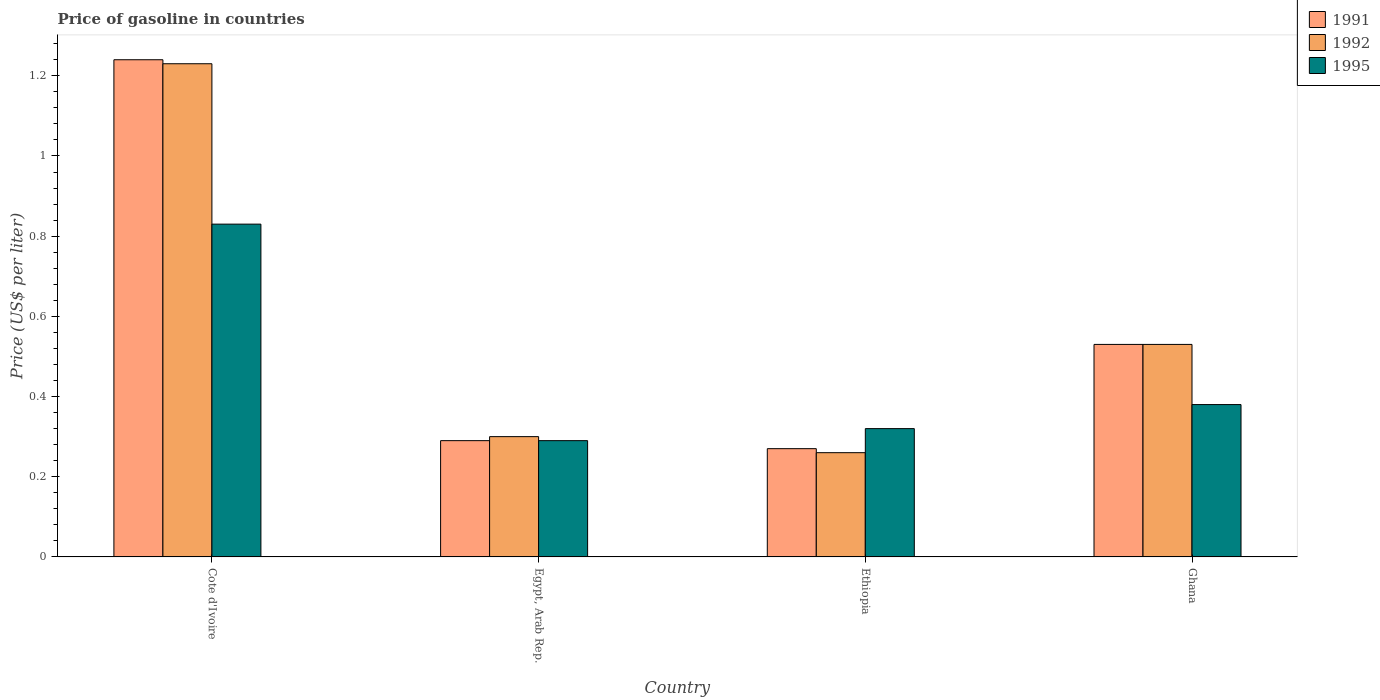How many different coloured bars are there?
Your answer should be compact. 3. Are the number of bars per tick equal to the number of legend labels?
Keep it short and to the point. Yes. How many bars are there on the 3rd tick from the right?
Provide a succinct answer. 3. What is the label of the 2nd group of bars from the left?
Keep it short and to the point. Egypt, Arab Rep. In how many cases, is the number of bars for a given country not equal to the number of legend labels?
Offer a very short reply. 0. What is the price of gasoline in 1992 in Ghana?
Give a very brief answer. 0.53. Across all countries, what is the maximum price of gasoline in 1991?
Make the answer very short. 1.24. Across all countries, what is the minimum price of gasoline in 1992?
Offer a terse response. 0.26. In which country was the price of gasoline in 1992 maximum?
Make the answer very short. Cote d'Ivoire. In which country was the price of gasoline in 1991 minimum?
Your response must be concise. Ethiopia. What is the total price of gasoline in 1995 in the graph?
Make the answer very short. 1.82. What is the difference between the price of gasoline in 1991 in Ethiopia and that in Ghana?
Provide a succinct answer. -0.26. What is the difference between the price of gasoline in 1995 in Ethiopia and the price of gasoline in 1992 in Cote d'Ivoire?
Provide a short and direct response. -0.91. What is the average price of gasoline in 1992 per country?
Your response must be concise. 0.58. What is the difference between the price of gasoline of/in 1991 and price of gasoline of/in 1992 in Ethiopia?
Ensure brevity in your answer.  0.01. In how many countries, is the price of gasoline in 1992 greater than 0.8 US$?
Offer a terse response. 1. What is the ratio of the price of gasoline in 1995 in Egypt, Arab Rep. to that in Ethiopia?
Give a very brief answer. 0.91. Is the price of gasoline in 1995 in Cote d'Ivoire less than that in Egypt, Arab Rep.?
Offer a terse response. No. What is the difference between the highest and the second highest price of gasoline in 1992?
Make the answer very short. -0.7. Is the sum of the price of gasoline in 1991 in Cote d'Ivoire and Ghana greater than the maximum price of gasoline in 1995 across all countries?
Provide a succinct answer. Yes. How many bars are there?
Give a very brief answer. 12. Are all the bars in the graph horizontal?
Make the answer very short. No. Are the values on the major ticks of Y-axis written in scientific E-notation?
Offer a very short reply. No. Does the graph contain grids?
Your answer should be very brief. No. Where does the legend appear in the graph?
Provide a succinct answer. Top right. What is the title of the graph?
Keep it short and to the point. Price of gasoline in countries. What is the label or title of the X-axis?
Offer a very short reply. Country. What is the label or title of the Y-axis?
Keep it short and to the point. Price (US$ per liter). What is the Price (US$ per liter) of 1991 in Cote d'Ivoire?
Offer a very short reply. 1.24. What is the Price (US$ per liter) in 1992 in Cote d'Ivoire?
Make the answer very short. 1.23. What is the Price (US$ per liter) in 1995 in Cote d'Ivoire?
Your answer should be very brief. 0.83. What is the Price (US$ per liter) in 1991 in Egypt, Arab Rep.?
Provide a succinct answer. 0.29. What is the Price (US$ per liter) of 1992 in Egypt, Arab Rep.?
Give a very brief answer. 0.3. What is the Price (US$ per liter) in 1995 in Egypt, Arab Rep.?
Your answer should be very brief. 0.29. What is the Price (US$ per liter) of 1991 in Ethiopia?
Your answer should be very brief. 0.27. What is the Price (US$ per liter) in 1992 in Ethiopia?
Your response must be concise. 0.26. What is the Price (US$ per liter) of 1995 in Ethiopia?
Ensure brevity in your answer.  0.32. What is the Price (US$ per liter) in 1991 in Ghana?
Give a very brief answer. 0.53. What is the Price (US$ per liter) in 1992 in Ghana?
Offer a very short reply. 0.53. What is the Price (US$ per liter) in 1995 in Ghana?
Your answer should be compact. 0.38. Across all countries, what is the maximum Price (US$ per liter) of 1991?
Provide a succinct answer. 1.24. Across all countries, what is the maximum Price (US$ per liter) in 1992?
Your response must be concise. 1.23. Across all countries, what is the maximum Price (US$ per liter) in 1995?
Keep it short and to the point. 0.83. Across all countries, what is the minimum Price (US$ per liter) in 1991?
Your answer should be very brief. 0.27. Across all countries, what is the minimum Price (US$ per liter) in 1992?
Keep it short and to the point. 0.26. Across all countries, what is the minimum Price (US$ per liter) in 1995?
Your answer should be compact. 0.29. What is the total Price (US$ per liter) of 1991 in the graph?
Provide a short and direct response. 2.33. What is the total Price (US$ per liter) of 1992 in the graph?
Your response must be concise. 2.32. What is the total Price (US$ per liter) in 1995 in the graph?
Provide a short and direct response. 1.82. What is the difference between the Price (US$ per liter) in 1991 in Cote d'Ivoire and that in Egypt, Arab Rep.?
Provide a short and direct response. 0.95. What is the difference between the Price (US$ per liter) in 1992 in Cote d'Ivoire and that in Egypt, Arab Rep.?
Give a very brief answer. 0.93. What is the difference between the Price (US$ per liter) of 1995 in Cote d'Ivoire and that in Egypt, Arab Rep.?
Provide a short and direct response. 0.54. What is the difference between the Price (US$ per liter) of 1991 in Cote d'Ivoire and that in Ethiopia?
Offer a very short reply. 0.97. What is the difference between the Price (US$ per liter) in 1992 in Cote d'Ivoire and that in Ethiopia?
Ensure brevity in your answer.  0.97. What is the difference between the Price (US$ per liter) in 1995 in Cote d'Ivoire and that in Ethiopia?
Your response must be concise. 0.51. What is the difference between the Price (US$ per liter) in 1991 in Cote d'Ivoire and that in Ghana?
Provide a succinct answer. 0.71. What is the difference between the Price (US$ per liter) in 1992 in Cote d'Ivoire and that in Ghana?
Offer a terse response. 0.7. What is the difference between the Price (US$ per liter) of 1995 in Cote d'Ivoire and that in Ghana?
Your response must be concise. 0.45. What is the difference between the Price (US$ per liter) of 1991 in Egypt, Arab Rep. and that in Ethiopia?
Keep it short and to the point. 0.02. What is the difference between the Price (US$ per liter) in 1995 in Egypt, Arab Rep. and that in Ethiopia?
Provide a succinct answer. -0.03. What is the difference between the Price (US$ per liter) of 1991 in Egypt, Arab Rep. and that in Ghana?
Ensure brevity in your answer.  -0.24. What is the difference between the Price (US$ per liter) in 1992 in Egypt, Arab Rep. and that in Ghana?
Provide a succinct answer. -0.23. What is the difference between the Price (US$ per liter) in 1995 in Egypt, Arab Rep. and that in Ghana?
Provide a succinct answer. -0.09. What is the difference between the Price (US$ per liter) of 1991 in Ethiopia and that in Ghana?
Offer a terse response. -0.26. What is the difference between the Price (US$ per liter) in 1992 in Ethiopia and that in Ghana?
Provide a succinct answer. -0.27. What is the difference between the Price (US$ per liter) of 1995 in Ethiopia and that in Ghana?
Keep it short and to the point. -0.06. What is the difference between the Price (US$ per liter) of 1991 in Cote d'Ivoire and the Price (US$ per liter) of 1992 in Egypt, Arab Rep.?
Keep it short and to the point. 0.94. What is the difference between the Price (US$ per liter) of 1991 in Cote d'Ivoire and the Price (US$ per liter) of 1995 in Egypt, Arab Rep.?
Keep it short and to the point. 0.95. What is the difference between the Price (US$ per liter) in 1992 in Cote d'Ivoire and the Price (US$ per liter) in 1995 in Ethiopia?
Give a very brief answer. 0.91. What is the difference between the Price (US$ per liter) of 1991 in Cote d'Ivoire and the Price (US$ per liter) of 1992 in Ghana?
Offer a very short reply. 0.71. What is the difference between the Price (US$ per liter) in 1991 in Cote d'Ivoire and the Price (US$ per liter) in 1995 in Ghana?
Give a very brief answer. 0.86. What is the difference between the Price (US$ per liter) of 1991 in Egypt, Arab Rep. and the Price (US$ per liter) of 1995 in Ethiopia?
Make the answer very short. -0.03. What is the difference between the Price (US$ per liter) of 1992 in Egypt, Arab Rep. and the Price (US$ per liter) of 1995 in Ethiopia?
Offer a terse response. -0.02. What is the difference between the Price (US$ per liter) of 1991 in Egypt, Arab Rep. and the Price (US$ per liter) of 1992 in Ghana?
Offer a very short reply. -0.24. What is the difference between the Price (US$ per liter) in 1991 in Egypt, Arab Rep. and the Price (US$ per liter) in 1995 in Ghana?
Make the answer very short. -0.09. What is the difference between the Price (US$ per liter) in 1992 in Egypt, Arab Rep. and the Price (US$ per liter) in 1995 in Ghana?
Your response must be concise. -0.08. What is the difference between the Price (US$ per liter) in 1991 in Ethiopia and the Price (US$ per liter) in 1992 in Ghana?
Your answer should be very brief. -0.26. What is the difference between the Price (US$ per liter) of 1991 in Ethiopia and the Price (US$ per liter) of 1995 in Ghana?
Ensure brevity in your answer.  -0.11. What is the difference between the Price (US$ per liter) of 1992 in Ethiopia and the Price (US$ per liter) of 1995 in Ghana?
Give a very brief answer. -0.12. What is the average Price (US$ per liter) of 1991 per country?
Give a very brief answer. 0.58. What is the average Price (US$ per liter) in 1992 per country?
Offer a terse response. 0.58. What is the average Price (US$ per liter) in 1995 per country?
Offer a terse response. 0.46. What is the difference between the Price (US$ per liter) in 1991 and Price (US$ per liter) in 1995 in Cote d'Ivoire?
Your answer should be very brief. 0.41. What is the difference between the Price (US$ per liter) of 1991 and Price (US$ per liter) of 1992 in Egypt, Arab Rep.?
Offer a terse response. -0.01. What is the difference between the Price (US$ per liter) of 1991 and Price (US$ per liter) of 1995 in Egypt, Arab Rep.?
Ensure brevity in your answer.  0. What is the difference between the Price (US$ per liter) of 1991 and Price (US$ per liter) of 1992 in Ethiopia?
Your answer should be very brief. 0.01. What is the difference between the Price (US$ per liter) of 1991 and Price (US$ per liter) of 1995 in Ethiopia?
Provide a succinct answer. -0.05. What is the difference between the Price (US$ per liter) in 1992 and Price (US$ per liter) in 1995 in Ethiopia?
Your response must be concise. -0.06. What is the ratio of the Price (US$ per liter) in 1991 in Cote d'Ivoire to that in Egypt, Arab Rep.?
Keep it short and to the point. 4.28. What is the ratio of the Price (US$ per liter) of 1992 in Cote d'Ivoire to that in Egypt, Arab Rep.?
Offer a very short reply. 4.1. What is the ratio of the Price (US$ per liter) of 1995 in Cote d'Ivoire to that in Egypt, Arab Rep.?
Make the answer very short. 2.86. What is the ratio of the Price (US$ per liter) of 1991 in Cote d'Ivoire to that in Ethiopia?
Your answer should be very brief. 4.59. What is the ratio of the Price (US$ per liter) in 1992 in Cote d'Ivoire to that in Ethiopia?
Keep it short and to the point. 4.73. What is the ratio of the Price (US$ per liter) of 1995 in Cote d'Ivoire to that in Ethiopia?
Offer a very short reply. 2.59. What is the ratio of the Price (US$ per liter) of 1991 in Cote d'Ivoire to that in Ghana?
Your response must be concise. 2.34. What is the ratio of the Price (US$ per liter) of 1992 in Cote d'Ivoire to that in Ghana?
Your response must be concise. 2.32. What is the ratio of the Price (US$ per liter) in 1995 in Cote d'Ivoire to that in Ghana?
Your answer should be compact. 2.18. What is the ratio of the Price (US$ per liter) in 1991 in Egypt, Arab Rep. to that in Ethiopia?
Provide a succinct answer. 1.07. What is the ratio of the Price (US$ per liter) in 1992 in Egypt, Arab Rep. to that in Ethiopia?
Offer a terse response. 1.15. What is the ratio of the Price (US$ per liter) of 1995 in Egypt, Arab Rep. to that in Ethiopia?
Offer a terse response. 0.91. What is the ratio of the Price (US$ per liter) in 1991 in Egypt, Arab Rep. to that in Ghana?
Ensure brevity in your answer.  0.55. What is the ratio of the Price (US$ per liter) of 1992 in Egypt, Arab Rep. to that in Ghana?
Offer a very short reply. 0.57. What is the ratio of the Price (US$ per liter) in 1995 in Egypt, Arab Rep. to that in Ghana?
Keep it short and to the point. 0.76. What is the ratio of the Price (US$ per liter) in 1991 in Ethiopia to that in Ghana?
Provide a succinct answer. 0.51. What is the ratio of the Price (US$ per liter) of 1992 in Ethiopia to that in Ghana?
Provide a succinct answer. 0.49. What is the ratio of the Price (US$ per liter) of 1995 in Ethiopia to that in Ghana?
Provide a succinct answer. 0.84. What is the difference between the highest and the second highest Price (US$ per liter) of 1991?
Provide a short and direct response. 0.71. What is the difference between the highest and the second highest Price (US$ per liter) in 1992?
Give a very brief answer. 0.7. What is the difference between the highest and the second highest Price (US$ per liter) in 1995?
Make the answer very short. 0.45. What is the difference between the highest and the lowest Price (US$ per liter) of 1991?
Ensure brevity in your answer.  0.97. What is the difference between the highest and the lowest Price (US$ per liter) in 1992?
Your answer should be very brief. 0.97. What is the difference between the highest and the lowest Price (US$ per liter) of 1995?
Make the answer very short. 0.54. 